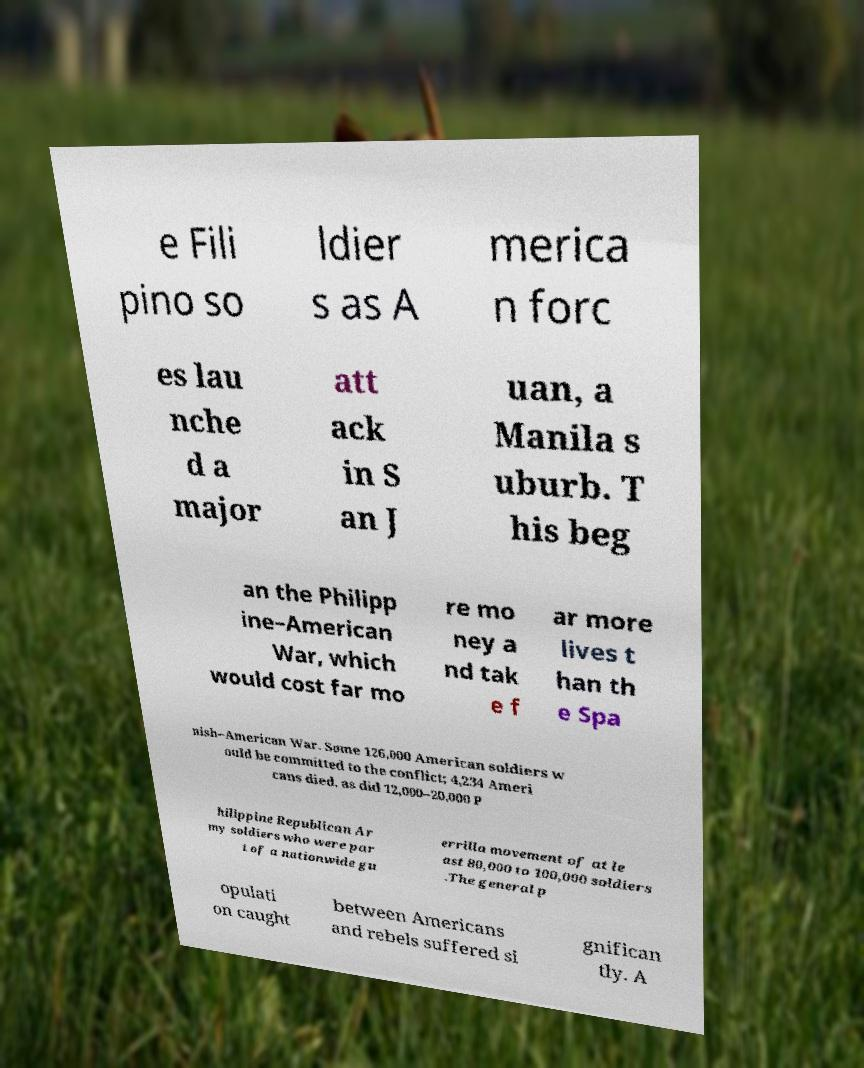There's text embedded in this image that I need extracted. Can you transcribe it verbatim? e Fili pino so ldier s as A merica n forc es lau nche d a major att ack in S an J uan, a Manila s uburb. T his beg an the Philipp ine–American War, which would cost far mo re mo ney a nd tak e f ar more lives t han th e Spa nish–American War. Some 126,000 American soldiers w ould be committed to the conflict; 4,234 Ameri cans died, as did 12,000–20,000 P hilippine Republican Ar my soldiers who were par t of a nationwide gu errilla movement of at le ast 80,000 to 100,000 soldiers .The general p opulati on caught between Americans and rebels suffered si gnifican tly. A 